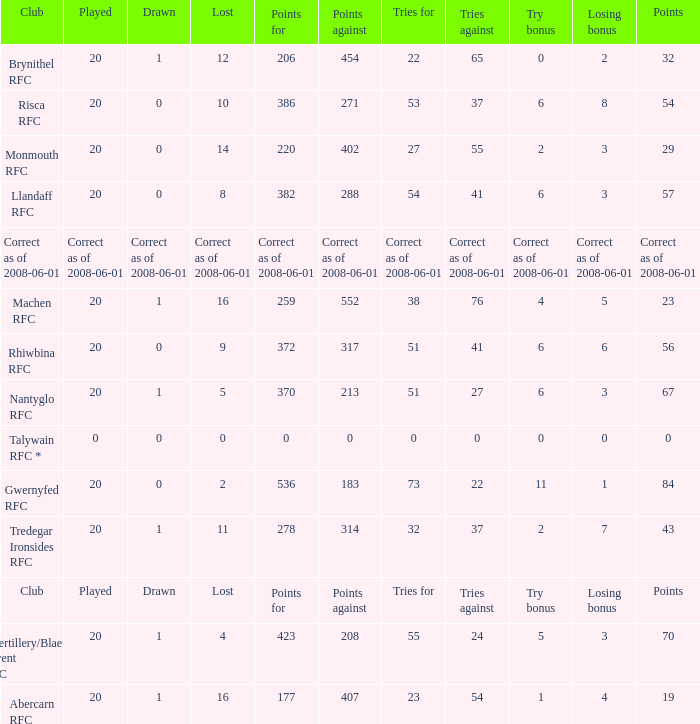If the points were 0, what were the tries for? 0.0. Would you mind parsing the complete table? {'header': ['Club', 'Played', 'Drawn', 'Lost', 'Points for', 'Points against', 'Tries for', 'Tries against', 'Try bonus', 'Losing bonus', 'Points'], 'rows': [['Brynithel RFC', '20', '1', '12', '206', '454', '22', '65', '0', '2', '32'], ['Risca RFC', '20', '0', '10', '386', '271', '53', '37', '6', '8', '54'], ['Monmouth RFC', '20', '0', '14', '220', '402', '27', '55', '2', '3', '29'], ['Llandaff RFC', '20', '0', '8', '382', '288', '54', '41', '6', '3', '57'], ['Correct as of 2008-06-01', 'Correct as of 2008-06-01', 'Correct as of 2008-06-01', 'Correct as of 2008-06-01', 'Correct as of 2008-06-01', 'Correct as of 2008-06-01', 'Correct as of 2008-06-01', 'Correct as of 2008-06-01', 'Correct as of 2008-06-01', 'Correct as of 2008-06-01', 'Correct as of 2008-06-01'], ['Machen RFC', '20', '1', '16', '259', '552', '38', '76', '4', '5', '23'], ['Rhiwbina RFC', '20', '0', '9', '372', '317', '51', '41', '6', '6', '56'], ['Nantyglo RFC', '20', '1', '5', '370', '213', '51', '27', '6', '3', '67'], ['Talywain RFC *', '0', '0', '0', '0', '0', '0', '0', '0', '0', '0'], ['Gwernyfed RFC', '20', '0', '2', '536', '183', '73', '22', '11', '1', '84'], ['Tredegar Ironsides RFC', '20', '1', '11', '278', '314', '32', '37', '2', '7', '43'], ['Club', 'Played', 'Drawn', 'Lost', 'Points for', 'Points against', 'Tries for', 'Tries against', 'Try bonus', 'Losing bonus', 'Points'], ['Abertillery/Blaenau Gwent RFC', '20', '1', '4', '423', '208', '55', '24', '5', '3', '70'], ['Abercarn RFC', '20', '1', '16', '177', '407', '23', '54', '1', '4', '19']]} 